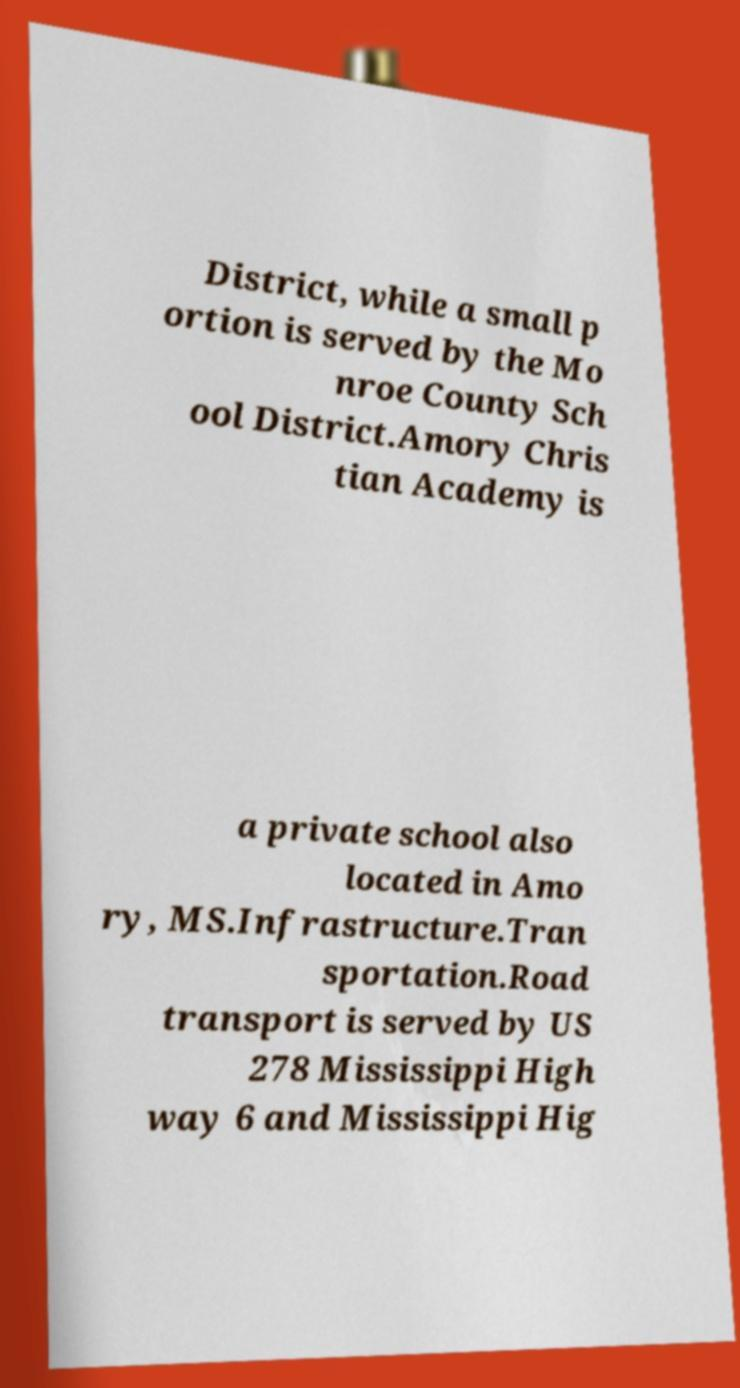Can you accurately transcribe the text from the provided image for me? District, while a small p ortion is served by the Mo nroe County Sch ool District.Amory Chris tian Academy is a private school also located in Amo ry, MS.Infrastructure.Tran sportation.Road transport is served by US 278 Mississippi High way 6 and Mississippi Hig 